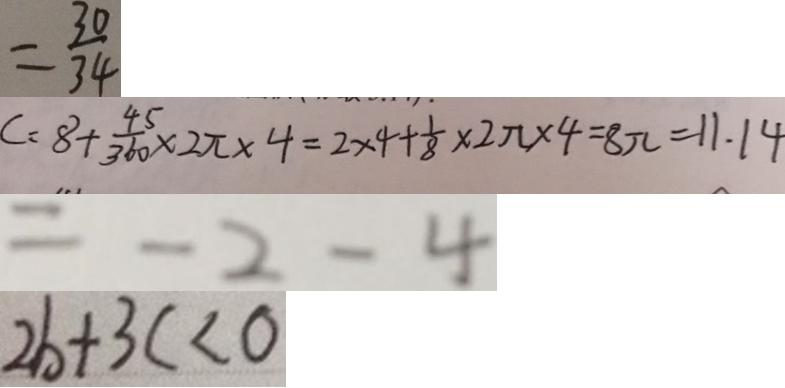<formula> <loc_0><loc_0><loc_500><loc_500>= \frac { 3 0 } { 3 4 } 
 C = 8 + \frac { 4 5 } { 3 6 0 } \times 2 \pi \times 4 = 2 \times 4 + \frac { 1 } { 8 } \times 2 \pi \times 4 = 8 \pi = 1 1 . 1 4 
 = - 2 - 4 
 2 b + 3 c < 0</formula> 